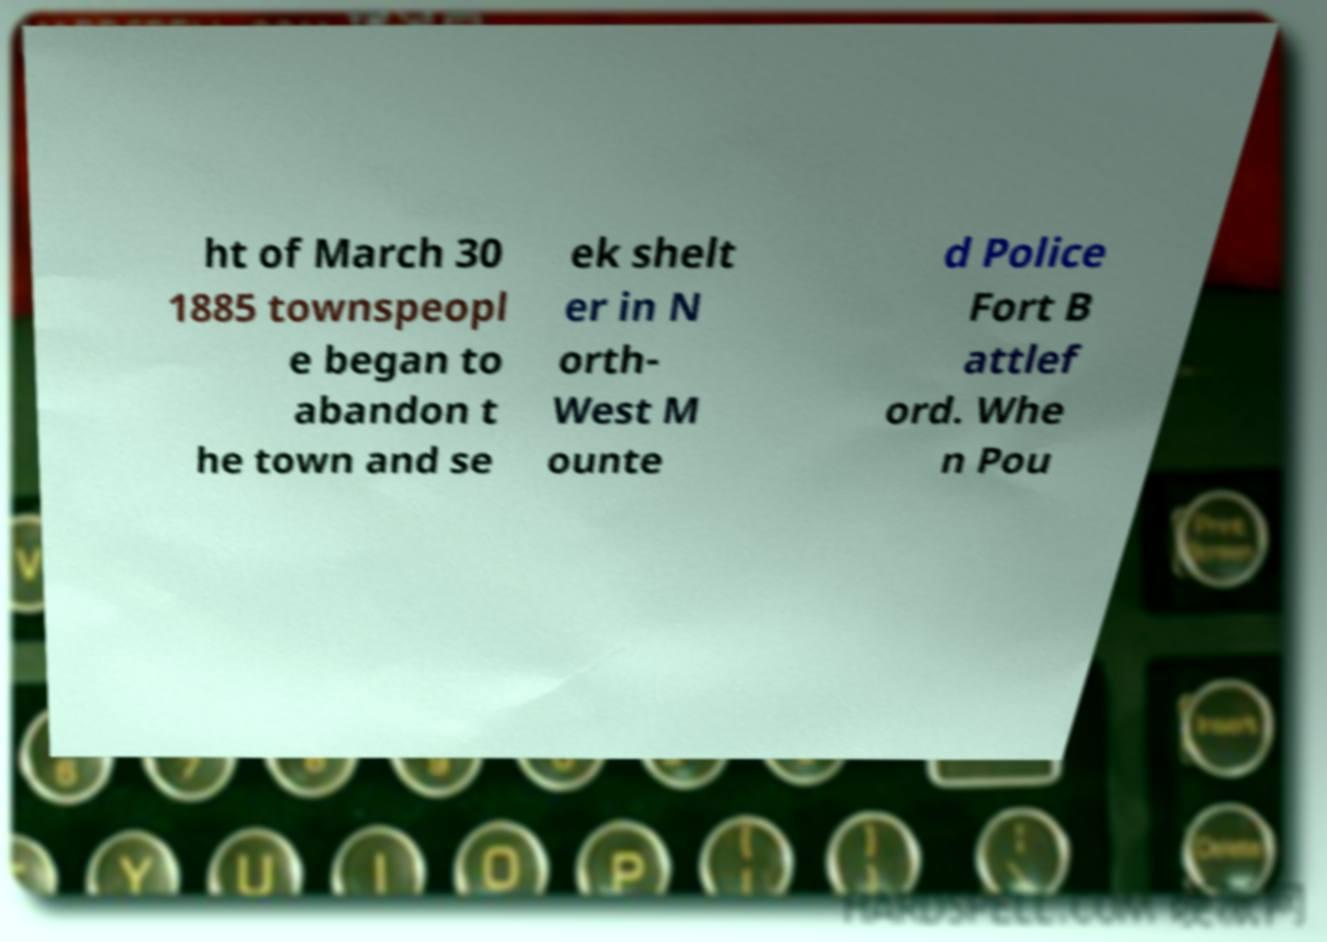Can you accurately transcribe the text from the provided image for me? ht of March 30 1885 townspeopl e began to abandon t he town and se ek shelt er in N orth- West M ounte d Police Fort B attlef ord. Whe n Pou 